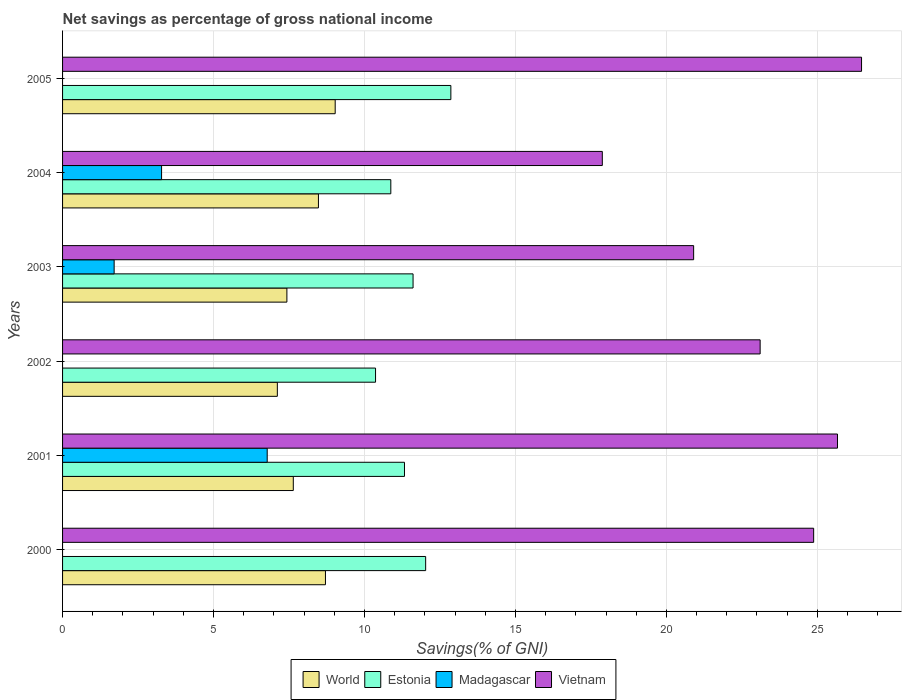How many groups of bars are there?
Keep it short and to the point. 6. Are the number of bars per tick equal to the number of legend labels?
Offer a very short reply. No. Are the number of bars on each tick of the Y-axis equal?
Your answer should be compact. No. What is the label of the 2nd group of bars from the top?
Keep it short and to the point. 2004. What is the total savings in Vietnam in 2003?
Your response must be concise. 20.9. Across all years, what is the maximum total savings in Estonia?
Provide a short and direct response. 12.86. Across all years, what is the minimum total savings in World?
Your answer should be very brief. 7.11. In which year was the total savings in Madagascar maximum?
Keep it short and to the point. 2001. What is the total total savings in World in the graph?
Keep it short and to the point. 48.4. What is the difference between the total savings in Estonia in 2001 and that in 2004?
Provide a short and direct response. 0.45. What is the difference between the total savings in Madagascar in 2004 and the total savings in World in 2000?
Offer a very short reply. -5.43. What is the average total savings in Vietnam per year?
Your response must be concise. 23.15. In the year 2002, what is the difference between the total savings in Estonia and total savings in World?
Offer a very short reply. 3.25. What is the ratio of the total savings in World in 2002 to that in 2004?
Your response must be concise. 0.84. Is the total savings in Estonia in 2000 less than that in 2003?
Offer a terse response. No. What is the difference between the highest and the second highest total savings in Madagascar?
Offer a terse response. 3.5. What is the difference between the highest and the lowest total savings in World?
Offer a terse response. 1.92. In how many years, is the total savings in Madagascar greater than the average total savings in Madagascar taken over all years?
Provide a short and direct response. 2. Is the sum of the total savings in World in 2002 and 2005 greater than the maximum total savings in Estonia across all years?
Your answer should be compact. Yes. Is it the case that in every year, the sum of the total savings in World and total savings in Vietnam is greater than the sum of total savings in Madagascar and total savings in Estonia?
Offer a terse response. Yes. Is it the case that in every year, the sum of the total savings in World and total savings in Madagascar is greater than the total savings in Estonia?
Your answer should be very brief. No. How many years are there in the graph?
Give a very brief answer. 6. Are the values on the major ticks of X-axis written in scientific E-notation?
Your response must be concise. No. Does the graph contain any zero values?
Make the answer very short. Yes. Does the graph contain grids?
Provide a succinct answer. Yes. How many legend labels are there?
Make the answer very short. 4. What is the title of the graph?
Your answer should be very brief. Net savings as percentage of gross national income. What is the label or title of the X-axis?
Provide a succinct answer. Savings(% of GNI). What is the label or title of the Y-axis?
Provide a short and direct response. Years. What is the Savings(% of GNI) of World in 2000?
Offer a very short reply. 8.71. What is the Savings(% of GNI) in Estonia in 2000?
Your answer should be compact. 12.03. What is the Savings(% of GNI) in Vietnam in 2000?
Your answer should be very brief. 24.88. What is the Savings(% of GNI) of World in 2001?
Give a very brief answer. 7.64. What is the Savings(% of GNI) of Estonia in 2001?
Your response must be concise. 11.33. What is the Savings(% of GNI) in Madagascar in 2001?
Your response must be concise. 6.78. What is the Savings(% of GNI) of Vietnam in 2001?
Make the answer very short. 25.67. What is the Savings(% of GNI) in World in 2002?
Ensure brevity in your answer.  7.11. What is the Savings(% of GNI) in Estonia in 2002?
Give a very brief answer. 10.37. What is the Savings(% of GNI) of Madagascar in 2002?
Provide a succinct answer. 0. What is the Savings(% of GNI) in Vietnam in 2002?
Offer a very short reply. 23.11. What is the Savings(% of GNI) in World in 2003?
Make the answer very short. 7.43. What is the Savings(% of GNI) of Estonia in 2003?
Make the answer very short. 11.61. What is the Savings(% of GNI) in Madagascar in 2003?
Keep it short and to the point. 1.71. What is the Savings(% of GNI) of Vietnam in 2003?
Offer a terse response. 20.9. What is the Savings(% of GNI) in World in 2004?
Provide a short and direct response. 8.48. What is the Savings(% of GNI) in Estonia in 2004?
Provide a short and direct response. 10.87. What is the Savings(% of GNI) of Madagascar in 2004?
Ensure brevity in your answer.  3.28. What is the Savings(% of GNI) in Vietnam in 2004?
Ensure brevity in your answer.  17.88. What is the Savings(% of GNI) of World in 2005?
Provide a succinct answer. 9.03. What is the Savings(% of GNI) of Estonia in 2005?
Make the answer very short. 12.86. What is the Savings(% of GNI) of Madagascar in 2005?
Your answer should be very brief. 0. What is the Savings(% of GNI) in Vietnam in 2005?
Keep it short and to the point. 26.46. Across all years, what is the maximum Savings(% of GNI) in World?
Your answer should be very brief. 9.03. Across all years, what is the maximum Savings(% of GNI) in Estonia?
Your answer should be compact. 12.86. Across all years, what is the maximum Savings(% of GNI) in Madagascar?
Offer a very short reply. 6.78. Across all years, what is the maximum Savings(% of GNI) of Vietnam?
Ensure brevity in your answer.  26.46. Across all years, what is the minimum Savings(% of GNI) in World?
Your response must be concise. 7.11. Across all years, what is the minimum Savings(% of GNI) of Estonia?
Your answer should be very brief. 10.37. Across all years, what is the minimum Savings(% of GNI) of Madagascar?
Provide a short and direct response. 0. Across all years, what is the minimum Savings(% of GNI) in Vietnam?
Keep it short and to the point. 17.88. What is the total Savings(% of GNI) in World in the graph?
Your response must be concise. 48.4. What is the total Savings(% of GNI) in Estonia in the graph?
Give a very brief answer. 69.06. What is the total Savings(% of GNI) in Madagascar in the graph?
Your answer should be very brief. 11.77. What is the total Savings(% of GNI) of Vietnam in the graph?
Provide a succinct answer. 138.9. What is the difference between the Savings(% of GNI) of World in 2000 and that in 2001?
Your answer should be compact. 1.06. What is the difference between the Savings(% of GNI) of Estonia in 2000 and that in 2001?
Offer a very short reply. 0.7. What is the difference between the Savings(% of GNI) of Vietnam in 2000 and that in 2001?
Offer a very short reply. -0.79. What is the difference between the Savings(% of GNI) in World in 2000 and that in 2002?
Your answer should be compact. 1.59. What is the difference between the Savings(% of GNI) of Estonia in 2000 and that in 2002?
Make the answer very short. 1.66. What is the difference between the Savings(% of GNI) of Vietnam in 2000 and that in 2002?
Your response must be concise. 1.77. What is the difference between the Savings(% of GNI) of World in 2000 and that in 2003?
Offer a terse response. 1.28. What is the difference between the Savings(% of GNI) of Estonia in 2000 and that in 2003?
Your answer should be compact. 0.42. What is the difference between the Savings(% of GNI) in Vietnam in 2000 and that in 2003?
Your answer should be compact. 3.98. What is the difference between the Savings(% of GNI) in World in 2000 and that in 2004?
Your answer should be compact. 0.23. What is the difference between the Savings(% of GNI) of Estonia in 2000 and that in 2004?
Your answer should be compact. 1.15. What is the difference between the Savings(% of GNI) of Vietnam in 2000 and that in 2004?
Offer a terse response. 7. What is the difference between the Savings(% of GNI) in World in 2000 and that in 2005?
Provide a short and direct response. -0.32. What is the difference between the Savings(% of GNI) in Estonia in 2000 and that in 2005?
Offer a very short reply. -0.83. What is the difference between the Savings(% of GNI) in Vietnam in 2000 and that in 2005?
Keep it short and to the point. -1.59. What is the difference between the Savings(% of GNI) in World in 2001 and that in 2002?
Your answer should be very brief. 0.53. What is the difference between the Savings(% of GNI) in Estonia in 2001 and that in 2002?
Offer a terse response. 0.96. What is the difference between the Savings(% of GNI) of Vietnam in 2001 and that in 2002?
Offer a very short reply. 2.56. What is the difference between the Savings(% of GNI) in World in 2001 and that in 2003?
Your response must be concise. 0.21. What is the difference between the Savings(% of GNI) of Estonia in 2001 and that in 2003?
Keep it short and to the point. -0.28. What is the difference between the Savings(% of GNI) of Madagascar in 2001 and that in 2003?
Offer a very short reply. 5.07. What is the difference between the Savings(% of GNI) in Vietnam in 2001 and that in 2003?
Provide a succinct answer. 4.76. What is the difference between the Savings(% of GNI) in World in 2001 and that in 2004?
Give a very brief answer. -0.83. What is the difference between the Savings(% of GNI) of Estonia in 2001 and that in 2004?
Offer a terse response. 0.45. What is the difference between the Savings(% of GNI) in Madagascar in 2001 and that in 2004?
Offer a terse response. 3.5. What is the difference between the Savings(% of GNI) in Vietnam in 2001 and that in 2004?
Make the answer very short. 7.79. What is the difference between the Savings(% of GNI) in World in 2001 and that in 2005?
Make the answer very short. -1.39. What is the difference between the Savings(% of GNI) in Estonia in 2001 and that in 2005?
Your response must be concise. -1.54. What is the difference between the Savings(% of GNI) of Vietnam in 2001 and that in 2005?
Your answer should be compact. -0.8. What is the difference between the Savings(% of GNI) of World in 2002 and that in 2003?
Provide a short and direct response. -0.32. What is the difference between the Savings(% of GNI) of Estonia in 2002 and that in 2003?
Ensure brevity in your answer.  -1.24. What is the difference between the Savings(% of GNI) in Vietnam in 2002 and that in 2003?
Your answer should be very brief. 2.2. What is the difference between the Savings(% of GNI) in World in 2002 and that in 2004?
Your answer should be very brief. -1.36. What is the difference between the Savings(% of GNI) in Estonia in 2002 and that in 2004?
Your answer should be compact. -0.51. What is the difference between the Savings(% of GNI) in Vietnam in 2002 and that in 2004?
Provide a succinct answer. 5.23. What is the difference between the Savings(% of GNI) of World in 2002 and that in 2005?
Your answer should be very brief. -1.92. What is the difference between the Savings(% of GNI) of Estonia in 2002 and that in 2005?
Make the answer very short. -2.49. What is the difference between the Savings(% of GNI) of Vietnam in 2002 and that in 2005?
Keep it short and to the point. -3.36. What is the difference between the Savings(% of GNI) of World in 2003 and that in 2004?
Your answer should be very brief. -1.04. What is the difference between the Savings(% of GNI) in Estonia in 2003 and that in 2004?
Keep it short and to the point. 0.74. What is the difference between the Savings(% of GNI) in Madagascar in 2003 and that in 2004?
Keep it short and to the point. -1.57. What is the difference between the Savings(% of GNI) in Vietnam in 2003 and that in 2004?
Provide a succinct answer. 3.03. What is the difference between the Savings(% of GNI) in World in 2003 and that in 2005?
Provide a short and direct response. -1.6. What is the difference between the Savings(% of GNI) of Estonia in 2003 and that in 2005?
Offer a terse response. -1.25. What is the difference between the Savings(% of GNI) of Vietnam in 2003 and that in 2005?
Your answer should be very brief. -5.56. What is the difference between the Savings(% of GNI) of World in 2004 and that in 2005?
Make the answer very short. -0.55. What is the difference between the Savings(% of GNI) of Estonia in 2004 and that in 2005?
Your response must be concise. -1.99. What is the difference between the Savings(% of GNI) in Vietnam in 2004 and that in 2005?
Keep it short and to the point. -8.59. What is the difference between the Savings(% of GNI) in World in 2000 and the Savings(% of GNI) in Estonia in 2001?
Your response must be concise. -2.62. What is the difference between the Savings(% of GNI) of World in 2000 and the Savings(% of GNI) of Madagascar in 2001?
Make the answer very short. 1.93. What is the difference between the Savings(% of GNI) of World in 2000 and the Savings(% of GNI) of Vietnam in 2001?
Offer a very short reply. -16.96. What is the difference between the Savings(% of GNI) of Estonia in 2000 and the Savings(% of GNI) of Madagascar in 2001?
Give a very brief answer. 5.25. What is the difference between the Savings(% of GNI) in Estonia in 2000 and the Savings(% of GNI) in Vietnam in 2001?
Give a very brief answer. -13.64. What is the difference between the Savings(% of GNI) in World in 2000 and the Savings(% of GNI) in Estonia in 2002?
Ensure brevity in your answer.  -1.66. What is the difference between the Savings(% of GNI) in World in 2000 and the Savings(% of GNI) in Vietnam in 2002?
Offer a terse response. -14.4. What is the difference between the Savings(% of GNI) of Estonia in 2000 and the Savings(% of GNI) of Vietnam in 2002?
Your answer should be very brief. -11.08. What is the difference between the Savings(% of GNI) in World in 2000 and the Savings(% of GNI) in Estonia in 2003?
Ensure brevity in your answer.  -2.9. What is the difference between the Savings(% of GNI) in World in 2000 and the Savings(% of GNI) in Madagascar in 2003?
Offer a terse response. 7. What is the difference between the Savings(% of GNI) in World in 2000 and the Savings(% of GNI) in Vietnam in 2003?
Make the answer very short. -12.2. What is the difference between the Savings(% of GNI) in Estonia in 2000 and the Savings(% of GNI) in Madagascar in 2003?
Your response must be concise. 10.32. What is the difference between the Savings(% of GNI) in Estonia in 2000 and the Savings(% of GNI) in Vietnam in 2003?
Your answer should be very brief. -8.88. What is the difference between the Savings(% of GNI) in World in 2000 and the Savings(% of GNI) in Estonia in 2004?
Your answer should be very brief. -2.17. What is the difference between the Savings(% of GNI) of World in 2000 and the Savings(% of GNI) of Madagascar in 2004?
Your response must be concise. 5.43. What is the difference between the Savings(% of GNI) in World in 2000 and the Savings(% of GNI) in Vietnam in 2004?
Your response must be concise. -9.17. What is the difference between the Savings(% of GNI) of Estonia in 2000 and the Savings(% of GNI) of Madagascar in 2004?
Provide a succinct answer. 8.75. What is the difference between the Savings(% of GNI) in Estonia in 2000 and the Savings(% of GNI) in Vietnam in 2004?
Provide a short and direct response. -5.85. What is the difference between the Savings(% of GNI) of World in 2000 and the Savings(% of GNI) of Estonia in 2005?
Your answer should be very brief. -4.15. What is the difference between the Savings(% of GNI) of World in 2000 and the Savings(% of GNI) of Vietnam in 2005?
Keep it short and to the point. -17.76. What is the difference between the Savings(% of GNI) in Estonia in 2000 and the Savings(% of GNI) in Vietnam in 2005?
Ensure brevity in your answer.  -14.44. What is the difference between the Savings(% of GNI) in World in 2001 and the Savings(% of GNI) in Estonia in 2002?
Your response must be concise. -2.72. What is the difference between the Savings(% of GNI) of World in 2001 and the Savings(% of GNI) of Vietnam in 2002?
Provide a short and direct response. -15.46. What is the difference between the Savings(% of GNI) of Estonia in 2001 and the Savings(% of GNI) of Vietnam in 2002?
Make the answer very short. -11.78. What is the difference between the Savings(% of GNI) of Madagascar in 2001 and the Savings(% of GNI) of Vietnam in 2002?
Your response must be concise. -16.33. What is the difference between the Savings(% of GNI) in World in 2001 and the Savings(% of GNI) in Estonia in 2003?
Provide a short and direct response. -3.97. What is the difference between the Savings(% of GNI) of World in 2001 and the Savings(% of GNI) of Madagascar in 2003?
Offer a very short reply. 5.93. What is the difference between the Savings(% of GNI) in World in 2001 and the Savings(% of GNI) in Vietnam in 2003?
Your answer should be compact. -13.26. What is the difference between the Savings(% of GNI) in Estonia in 2001 and the Savings(% of GNI) in Madagascar in 2003?
Offer a terse response. 9.62. What is the difference between the Savings(% of GNI) of Estonia in 2001 and the Savings(% of GNI) of Vietnam in 2003?
Your response must be concise. -9.58. What is the difference between the Savings(% of GNI) of Madagascar in 2001 and the Savings(% of GNI) of Vietnam in 2003?
Make the answer very short. -14.12. What is the difference between the Savings(% of GNI) of World in 2001 and the Savings(% of GNI) of Estonia in 2004?
Your response must be concise. -3.23. What is the difference between the Savings(% of GNI) of World in 2001 and the Savings(% of GNI) of Madagascar in 2004?
Provide a short and direct response. 4.36. What is the difference between the Savings(% of GNI) of World in 2001 and the Savings(% of GNI) of Vietnam in 2004?
Your response must be concise. -10.24. What is the difference between the Savings(% of GNI) of Estonia in 2001 and the Savings(% of GNI) of Madagascar in 2004?
Give a very brief answer. 8.05. What is the difference between the Savings(% of GNI) in Estonia in 2001 and the Savings(% of GNI) in Vietnam in 2004?
Your answer should be compact. -6.55. What is the difference between the Savings(% of GNI) of Madagascar in 2001 and the Savings(% of GNI) of Vietnam in 2004?
Your response must be concise. -11.1. What is the difference between the Savings(% of GNI) in World in 2001 and the Savings(% of GNI) in Estonia in 2005?
Offer a terse response. -5.22. What is the difference between the Savings(% of GNI) in World in 2001 and the Savings(% of GNI) in Vietnam in 2005?
Your answer should be compact. -18.82. What is the difference between the Savings(% of GNI) of Estonia in 2001 and the Savings(% of GNI) of Vietnam in 2005?
Offer a very short reply. -15.14. What is the difference between the Savings(% of GNI) of Madagascar in 2001 and the Savings(% of GNI) of Vietnam in 2005?
Offer a very short reply. -19.69. What is the difference between the Savings(% of GNI) in World in 2002 and the Savings(% of GNI) in Estonia in 2003?
Give a very brief answer. -4.5. What is the difference between the Savings(% of GNI) of World in 2002 and the Savings(% of GNI) of Madagascar in 2003?
Provide a short and direct response. 5.41. What is the difference between the Savings(% of GNI) in World in 2002 and the Savings(% of GNI) in Vietnam in 2003?
Offer a very short reply. -13.79. What is the difference between the Savings(% of GNI) of Estonia in 2002 and the Savings(% of GNI) of Madagascar in 2003?
Provide a succinct answer. 8.66. What is the difference between the Savings(% of GNI) in Estonia in 2002 and the Savings(% of GNI) in Vietnam in 2003?
Make the answer very short. -10.54. What is the difference between the Savings(% of GNI) of World in 2002 and the Savings(% of GNI) of Estonia in 2004?
Your response must be concise. -3.76. What is the difference between the Savings(% of GNI) of World in 2002 and the Savings(% of GNI) of Madagascar in 2004?
Your answer should be compact. 3.83. What is the difference between the Savings(% of GNI) of World in 2002 and the Savings(% of GNI) of Vietnam in 2004?
Ensure brevity in your answer.  -10.76. What is the difference between the Savings(% of GNI) of Estonia in 2002 and the Savings(% of GNI) of Madagascar in 2004?
Your answer should be compact. 7.09. What is the difference between the Savings(% of GNI) of Estonia in 2002 and the Savings(% of GNI) of Vietnam in 2004?
Offer a terse response. -7.51. What is the difference between the Savings(% of GNI) of World in 2002 and the Savings(% of GNI) of Estonia in 2005?
Give a very brief answer. -5.75. What is the difference between the Savings(% of GNI) of World in 2002 and the Savings(% of GNI) of Vietnam in 2005?
Give a very brief answer. -19.35. What is the difference between the Savings(% of GNI) of Estonia in 2002 and the Savings(% of GNI) of Vietnam in 2005?
Ensure brevity in your answer.  -16.1. What is the difference between the Savings(% of GNI) of World in 2003 and the Savings(% of GNI) of Estonia in 2004?
Your response must be concise. -3.44. What is the difference between the Savings(% of GNI) in World in 2003 and the Savings(% of GNI) in Madagascar in 2004?
Keep it short and to the point. 4.15. What is the difference between the Savings(% of GNI) in World in 2003 and the Savings(% of GNI) in Vietnam in 2004?
Your answer should be compact. -10.45. What is the difference between the Savings(% of GNI) of Estonia in 2003 and the Savings(% of GNI) of Madagascar in 2004?
Your response must be concise. 8.33. What is the difference between the Savings(% of GNI) in Estonia in 2003 and the Savings(% of GNI) in Vietnam in 2004?
Your answer should be compact. -6.27. What is the difference between the Savings(% of GNI) in Madagascar in 2003 and the Savings(% of GNI) in Vietnam in 2004?
Offer a terse response. -16.17. What is the difference between the Savings(% of GNI) of World in 2003 and the Savings(% of GNI) of Estonia in 2005?
Offer a terse response. -5.43. What is the difference between the Savings(% of GNI) in World in 2003 and the Savings(% of GNI) in Vietnam in 2005?
Your response must be concise. -19.03. What is the difference between the Savings(% of GNI) in Estonia in 2003 and the Savings(% of GNI) in Vietnam in 2005?
Give a very brief answer. -14.86. What is the difference between the Savings(% of GNI) of Madagascar in 2003 and the Savings(% of GNI) of Vietnam in 2005?
Provide a short and direct response. -24.76. What is the difference between the Savings(% of GNI) of World in 2004 and the Savings(% of GNI) of Estonia in 2005?
Your answer should be very brief. -4.39. What is the difference between the Savings(% of GNI) of World in 2004 and the Savings(% of GNI) of Vietnam in 2005?
Make the answer very short. -17.99. What is the difference between the Savings(% of GNI) of Estonia in 2004 and the Savings(% of GNI) of Vietnam in 2005?
Your answer should be very brief. -15.59. What is the difference between the Savings(% of GNI) of Madagascar in 2004 and the Savings(% of GNI) of Vietnam in 2005?
Your response must be concise. -23.18. What is the average Savings(% of GNI) of World per year?
Provide a short and direct response. 8.07. What is the average Savings(% of GNI) of Estonia per year?
Ensure brevity in your answer.  11.51. What is the average Savings(% of GNI) of Madagascar per year?
Provide a succinct answer. 1.96. What is the average Savings(% of GNI) of Vietnam per year?
Make the answer very short. 23.15. In the year 2000, what is the difference between the Savings(% of GNI) of World and Savings(% of GNI) of Estonia?
Keep it short and to the point. -3.32. In the year 2000, what is the difference between the Savings(% of GNI) of World and Savings(% of GNI) of Vietnam?
Offer a very short reply. -16.17. In the year 2000, what is the difference between the Savings(% of GNI) of Estonia and Savings(% of GNI) of Vietnam?
Provide a succinct answer. -12.85. In the year 2001, what is the difference between the Savings(% of GNI) in World and Savings(% of GNI) in Estonia?
Provide a succinct answer. -3.68. In the year 2001, what is the difference between the Savings(% of GNI) in World and Savings(% of GNI) in Madagascar?
Ensure brevity in your answer.  0.86. In the year 2001, what is the difference between the Savings(% of GNI) in World and Savings(% of GNI) in Vietnam?
Your response must be concise. -18.03. In the year 2001, what is the difference between the Savings(% of GNI) of Estonia and Savings(% of GNI) of Madagascar?
Your answer should be very brief. 4.55. In the year 2001, what is the difference between the Savings(% of GNI) in Estonia and Savings(% of GNI) in Vietnam?
Your answer should be very brief. -14.34. In the year 2001, what is the difference between the Savings(% of GNI) of Madagascar and Savings(% of GNI) of Vietnam?
Provide a short and direct response. -18.89. In the year 2002, what is the difference between the Savings(% of GNI) in World and Savings(% of GNI) in Estonia?
Provide a short and direct response. -3.25. In the year 2002, what is the difference between the Savings(% of GNI) of World and Savings(% of GNI) of Vietnam?
Your answer should be compact. -15.99. In the year 2002, what is the difference between the Savings(% of GNI) of Estonia and Savings(% of GNI) of Vietnam?
Your response must be concise. -12.74. In the year 2003, what is the difference between the Savings(% of GNI) of World and Savings(% of GNI) of Estonia?
Your answer should be compact. -4.18. In the year 2003, what is the difference between the Savings(% of GNI) in World and Savings(% of GNI) in Madagascar?
Make the answer very short. 5.72. In the year 2003, what is the difference between the Savings(% of GNI) of World and Savings(% of GNI) of Vietnam?
Ensure brevity in your answer.  -13.47. In the year 2003, what is the difference between the Savings(% of GNI) of Estonia and Savings(% of GNI) of Madagascar?
Ensure brevity in your answer.  9.9. In the year 2003, what is the difference between the Savings(% of GNI) in Estonia and Savings(% of GNI) in Vietnam?
Your response must be concise. -9.29. In the year 2003, what is the difference between the Savings(% of GNI) of Madagascar and Savings(% of GNI) of Vietnam?
Your answer should be very brief. -19.19. In the year 2004, what is the difference between the Savings(% of GNI) in World and Savings(% of GNI) in Estonia?
Your response must be concise. -2.4. In the year 2004, what is the difference between the Savings(% of GNI) in World and Savings(% of GNI) in Madagascar?
Your answer should be compact. 5.2. In the year 2004, what is the difference between the Savings(% of GNI) of World and Savings(% of GNI) of Vietnam?
Offer a terse response. -9.4. In the year 2004, what is the difference between the Savings(% of GNI) in Estonia and Savings(% of GNI) in Madagascar?
Give a very brief answer. 7.59. In the year 2004, what is the difference between the Savings(% of GNI) of Estonia and Savings(% of GNI) of Vietnam?
Give a very brief answer. -7.01. In the year 2004, what is the difference between the Savings(% of GNI) of Madagascar and Savings(% of GNI) of Vietnam?
Offer a very short reply. -14.6. In the year 2005, what is the difference between the Savings(% of GNI) of World and Savings(% of GNI) of Estonia?
Provide a short and direct response. -3.83. In the year 2005, what is the difference between the Savings(% of GNI) in World and Savings(% of GNI) in Vietnam?
Make the answer very short. -17.43. In the year 2005, what is the difference between the Savings(% of GNI) in Estonia and Savings(% of GNI) in Vietnam?
Provide a short and direct response. -13.6. What is the ratio of the Savings(% of GNI) of World in 2000 to that in 2001?
Offer a terse response. 1.14. What is the ratio of the Savings(% of GNI) of Estonia in 2000 to that in 2001?
Offer a very short reply. 1.06. What is the ratio of the Savings(% of GNI) in Vietnam in 2000 to that in 2001?
Make the answer very short. 0.97. What is the ratio of the Savings(% of GNI) in World in 2000 to that in 2002?
Keep it short and to the point. 1.22. What is the ratio of the Savings(% of GNI) of Estonia in 2000 to that in 2002?
Your answer should be compact. 1.16. What is the ratio of the Savings(% of GNI) of Vietnam in 2000 to that in 2002?
Keep it short and to the point. 1.08. What is the ratio of the Savings(% of GNI) in World in 2000 to that in 2003?
Offer a terse response. 1.17. What is the ratio of the Savings(% of GNI) in Estonia in 2000 to that in 2003?
Provide a succinct answer. 1.04. What is the ratio of the Savings(% of GNI) in Vietnam in 2000 to that in 2003?
Provide a short and direct response. 1.19. What is the ratio of the Savings(% of GNI) in World in 2000 to that in 2004?
Provide a short and direct response. 1.03. What is the ratio of the Savings(% of GNI) of Estonia in 2000 to that in 2004?
Offer a terse response. 1.11. What is the ratio of the Savings(% of GNI) of Vietnam in 2000 to that in 2004?
Ensure brevity in your answer.  1.39. What is the ratio of the Savings(% of GNI) of World in 2000 to that in 2005?
Ensure brevity in your answer.  0.96. What is the ratio of the Savings(% of GNI) in Estonia in 2000 to that in 2005?
Make the answer very short. 0.94. What is the ratio of the Savings(% of GNI) in Vietnam in 2000 to that in 2005?
Give a very brief answer. 0.94. What is the ratio of the Savings(% of GNI) in World in 2001 to that in 2002?
Provide a short and direct response. 1.07. What is the ratio of the Savings(% of GNI) of Estonia in 2001 to that in 2002?
Your answer should be compact. 1.09. What is the ratio of the Savings(% of GNI) in Vietnam in 2001 to that in 2002?
Provide a succinct answer. 1.11. What is the ratio of the Savings(% of GNI) of World in 2001 to that in 2003?
Keep it short and to the point. 1.03. What is the ratio of the Savings(% of GNI) in Estonia in 2001 to that in 2003?
Your response must be concise. 0.98. What is the ratio of the Savings(% of GNI) in Madagascar in 2001 to that in 2003?
Offer a terse response. 3.97. What is the ratio of the Savings(% of GNI) of Vietnam in 2001 to that in 2003?
Ensure brevity in your answer.  1.23. What is the ratio of the Savings(% of GNI) in World in 2001 to that in 2004?
Provide a short and direct response. 0.9. What is the ratio of the Savings(% of GNI) in Estonia in 2001 to that in 2004?
Ensure brevity in your answer.  1.04. What is the ratio of the Savings(% of GNI) in Madagascar in 2001 to that in 2004?
Your answer should be very brief. 2.07. What is the ratio of the Savings(% of GNI) of Vietnam in 2001 to that in 2004?
Ensure brevity in your answer.  1.44. What is the ratio of the Savings(% of GNI) in World in 2001 to that in 2005?
Keep it short and to the point. 0.85. What is the ratio of the Savings(% of GNI) of Estonia in 2001 to that in 2005?
Your answer should be compact. 0.88. What is the ratio of the Savings(% of GNI) of Vietnam in 2001 to that in 2005?
Your answer should be very brief. 0.97. What is the ratio of the Savings(% of GNI) in World in 2002 to that in 2003?
Keep it short and to the point. 0.96. What is the ratio of the Savings(% of GNI) in Estonia in 2002 to that in 2003?
Provide a succinct answer. 0.89. What is the ratio of the Savings(% of GNI) of Vietnam in 2002 to that in 2003?
Ensure brevity in your answer.  1.11. What is the ratio of the Savings(% of GNI) in World in 2002 to that in 2004?
Your answer should be compact. 0.84. What is the ratio of the Savings(% of GNI) in Estonia in 2002 to that in 2004?
Your answer should be compact. 0.95. What is the ratio of the Savings(% of GNI) in Vietnam in 2002 to that in 2004?
Your answer should be compact. 1.29. What is the ratio of the Savings(% of GNI) of World in 2002 to that in 2005?
Provide a succinct answer. 0.79. What is the ratio of the Savings(% of GNI) of Estonia in 2002 to that in 2005?
Your answer should be very brief. 0.81. What is the ratio of the Savings(% of GNI) of Vietnam in 2002 to that in 2005?
Keep it short and to the point. 0.87. What is the ratio of the Savings(% of GNI) in World in 2003 to that in 2004?
Offer a very short reply. 0.88. What is the ratio of the Savings(% of GNI) in Estonia in 2003 to that in 2004?
Provide a short and direct response. 1.07. What is the ratio of the Savings(% of GNI) of Madagascar in 2003 to that in 2004?
Provide a short and direct response. 0.52. What is the ratio of the Savings(% of GNI) of Vietnam in 2003 to that in 2004?
Your answer should be very brief. 1.17. What is the ratio of the Savings(% of GNI) in World in 2003 to that in 2005?
Offer a very short reply. 0.82. What is the ratio of the Savings(% of GNI) in Estonia in 2003 to that in 2005?
Provide a succinct answer. 0.9. What is the ratio of the Savings(% of GNI) of Vietnam in 2003 to that in 2005?
Offer a terse response. 0.79. What is the ratio of the Savings(% of GNI) of World in 2004 to that in 2005?
Keep it short and to the point. 0.94. What is the ratio of the Savings(% of GNI) of Estonia in 2004 to that in 2005?
Your answer should be compact. 0.85. What is the ratio of the Savings(% of GNI) in Vietnam in 2004 to that in 2005?
Provide a short and direct response. 0.68. What is the difference between the highest and the second highest Savings(% of GNI) in World?
Provide a succinct answer. 0.32. What is the difference between the highest and the second highest Savings(% of GNI) in Estonia?
Provide a short and direct response. 0.83. What is the difference between the highest and the second highest Savings(% of GNI) in Madagascar?
Make the answer very short. 3.5. What is the difference between the highest and the second highest Savings(% of GNI) of Vietnam?
Provide a short and direct response. 0.8. What is the difference between the highest and the lowest Savings(% of GNI) in World?
Offer a very short reply. 1.92. What is the difference between the highest and the lowest Savings(% of GNI) of Estonia?
Ensure brevity in your answer.  2.49. What is the difference between the highest and the lowest Savings(% of GNI) of Madagascar?
Your answer should be compact. 6.78. What is the difference between the highest and the lowest Savings(% of GNI) in Vietnam?
Ensure brevity in your answer.  8.59. 